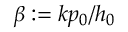<formula> <loc_0><loc_0><loc_500><loc_500>\beta \colon = k p _ { 0 } / h _ { 0 }</formula> 